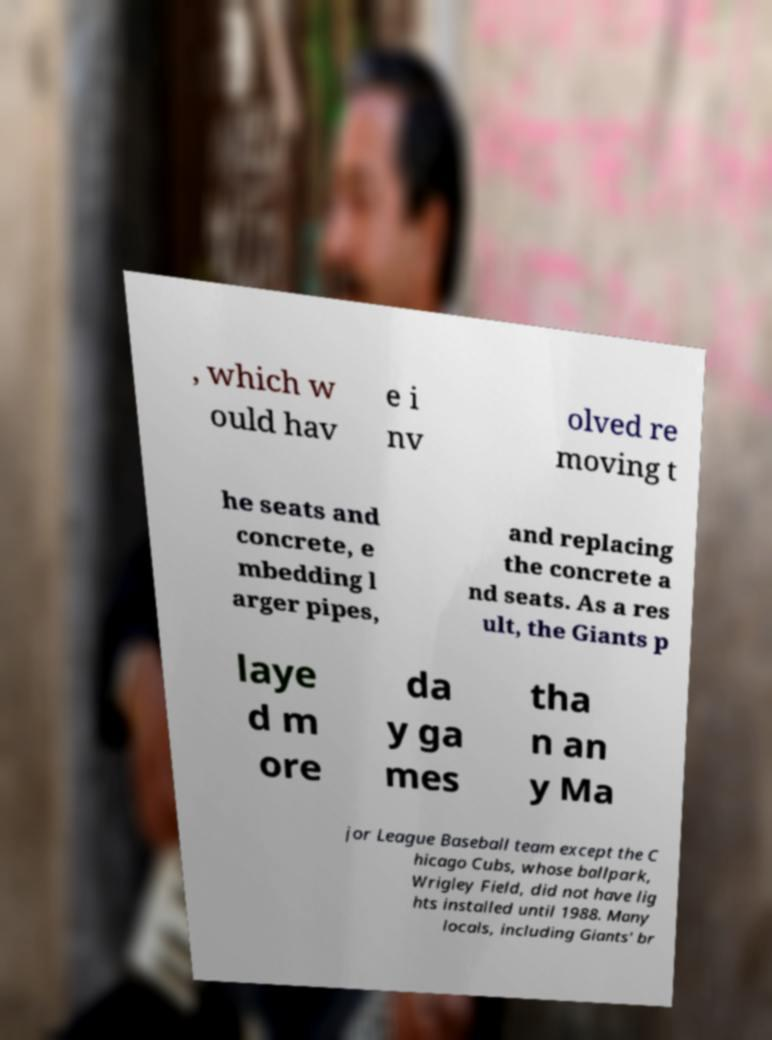Please identify and transcribe the text found in this image. , which w ould hav e i nv olved re moving t he seats and concrete, e mbedding l arger pipes, and replacing the concrete a nd seats. As a res ult, the Giants p laye d m ore da y ga mes tha n an y Ma jor League Baseball team except the C hicago Cubs, whose ballpark, Wrigley Field, did not have lig hts installed until 1988. Many locals, including Giants' br 